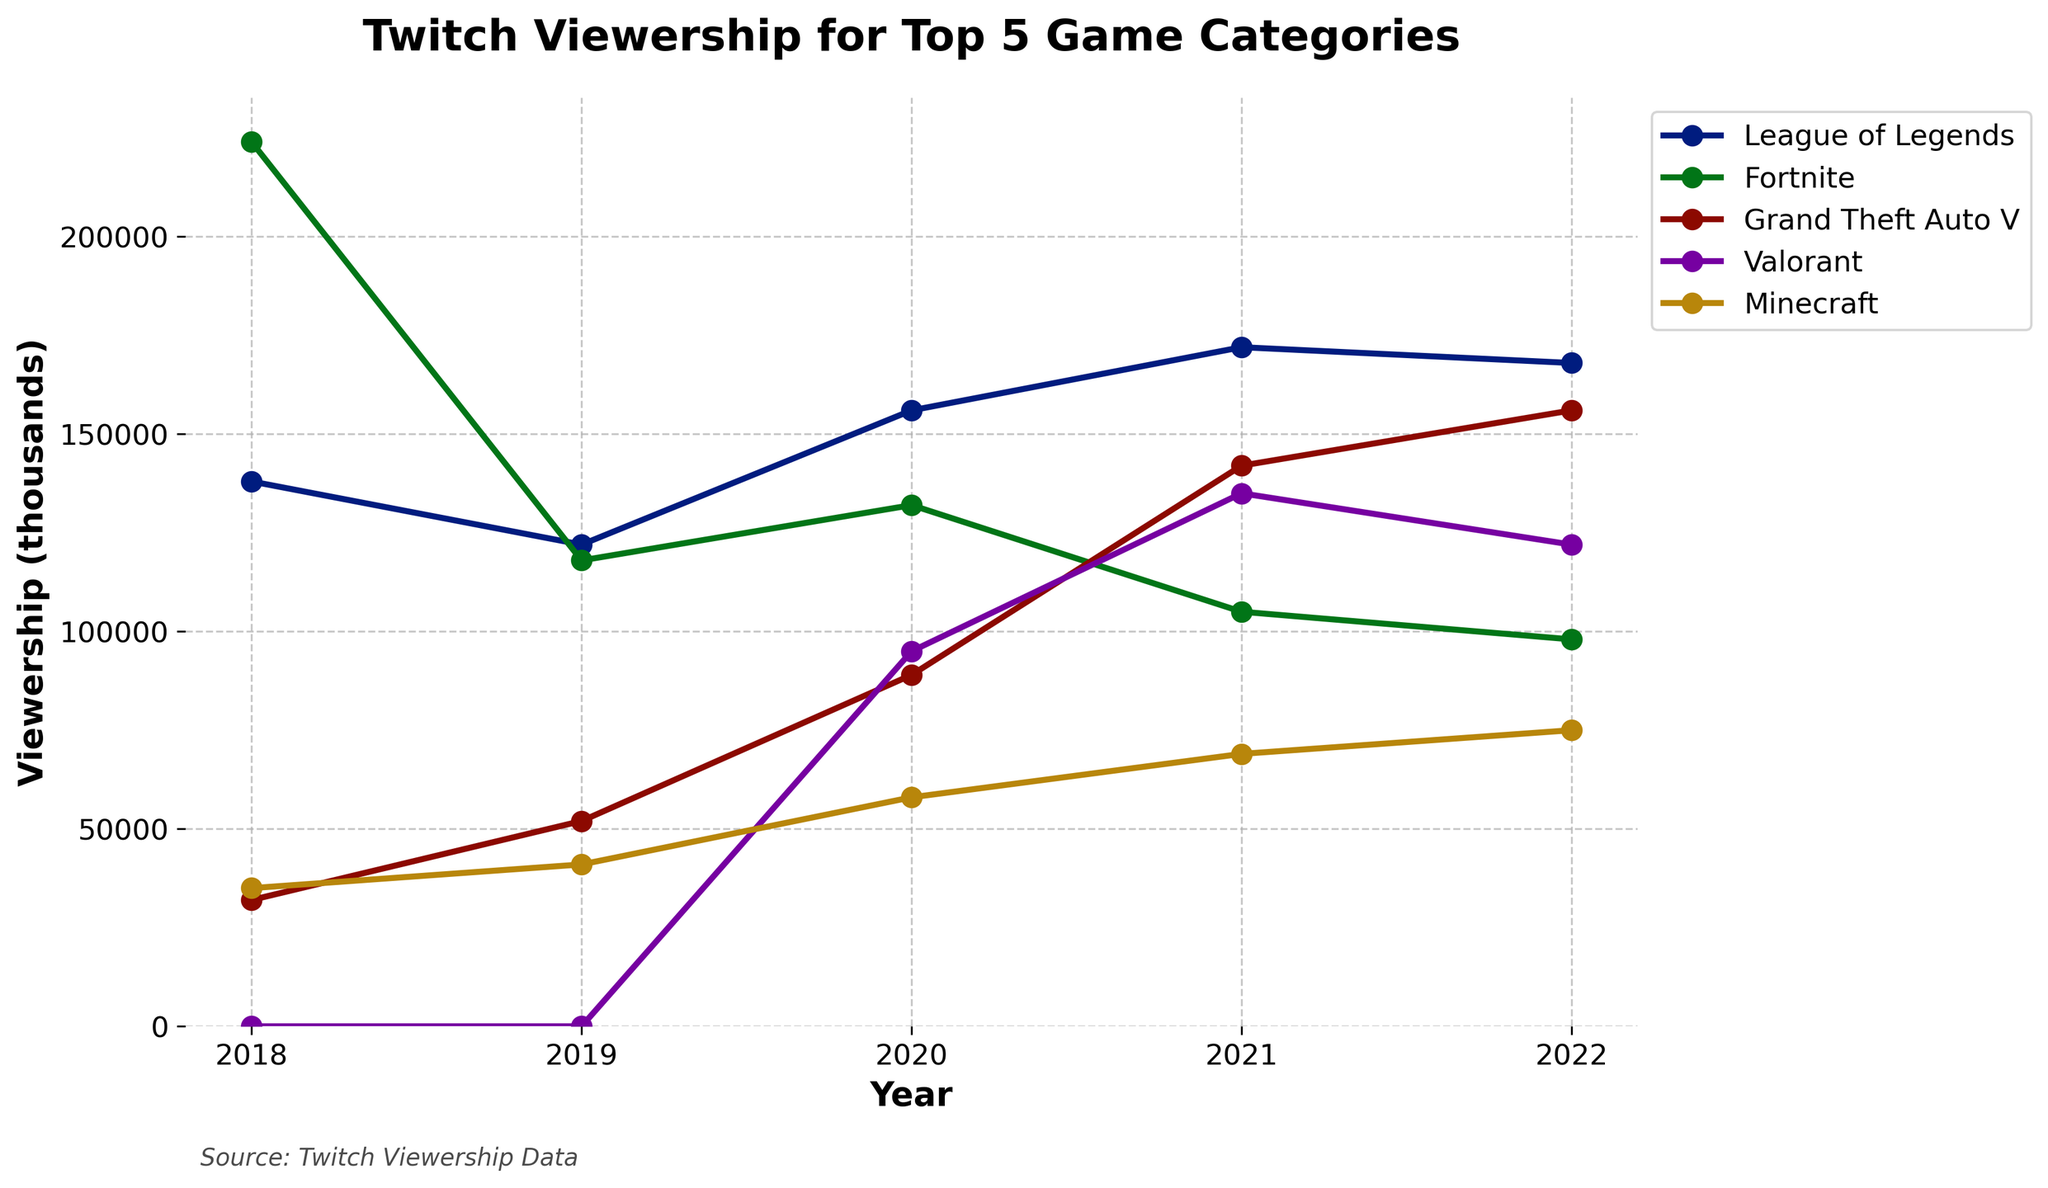Which game had the highest viewership in 2018? In the year 2018, the game with the highest viewership can be identified by looking at the data points on the respective lines for each game category. The highest point corresponds to Fortnite with 224,000.
Answer: Fortnite Which game saw the largest increase in viewership from 2019 to 2020? By calculating the difference in viewership between years 2019 and 2020 for each game, it shows that Valorant increased the most, going from 0 to 95,000, an increase of 95,000.
Answer: Valorant What is the average viewership for League of Legends over the 5 years? To find the average, sum the viewership numbers for League of Legends (138,000 + 122,000 + 156,000 + 172,000 + 168,000) which equals 756,000, and then divide by 5 (number of years): 756,000 / 5 equals 151,200.
Answer: 151,200 How did Minecraft's viewership change from 2018 to 2022? By comparing the values in 2018 and 2022 for Minecraft, viewership increased from 35,000 to 75,000, which is a difference of (75,000 - 35,000) = 40,000.
Answer: Increased by 40,000 Which year showed the highest overall average viewership for all games? First, calculate the average viewership for each year: 2018 (139,800), 2019 (67,800), 2020 (106,200), 2021 (124,600), 2022 (123,800). Among these, 2018 has the highest average viewership.
Answer: 2018 In 2022, which game had a higher viewership: Valorant or Grand Theft Auto V? By comparing the viewership figures for the year 2022, Valorant (122,000) is lower than Grand Theft Auto V (156,000).
Answer: Grand Theft Auto V What was the viewership trend for Fortnite from 2018 to 2022? Observing the viewership numbers for Fortnite: 224,000 (2018), 118,000 (2019), 132,000 (2020), 105,000 (2021), 98,000 (2022), the trend is a consistent decline over these years.
Answer: Declining Which game's viewership peaked in 2020 and then decreased the following year? From the data, viewership for League of Legends peaked in 2020 at 156,000 and then decreased in 2021 to 172,000.
Answer: League of Legends What's the total viewership for all 5 games in 2021? The sum of viewership for all games in 2021 is League of Legends (172,000) + Fortnite (105,000) + Grand Theft Auto V (142,000) + Valorant (135,000) + Minecraft (69,000) = 623,000.
Answer: 623,000 